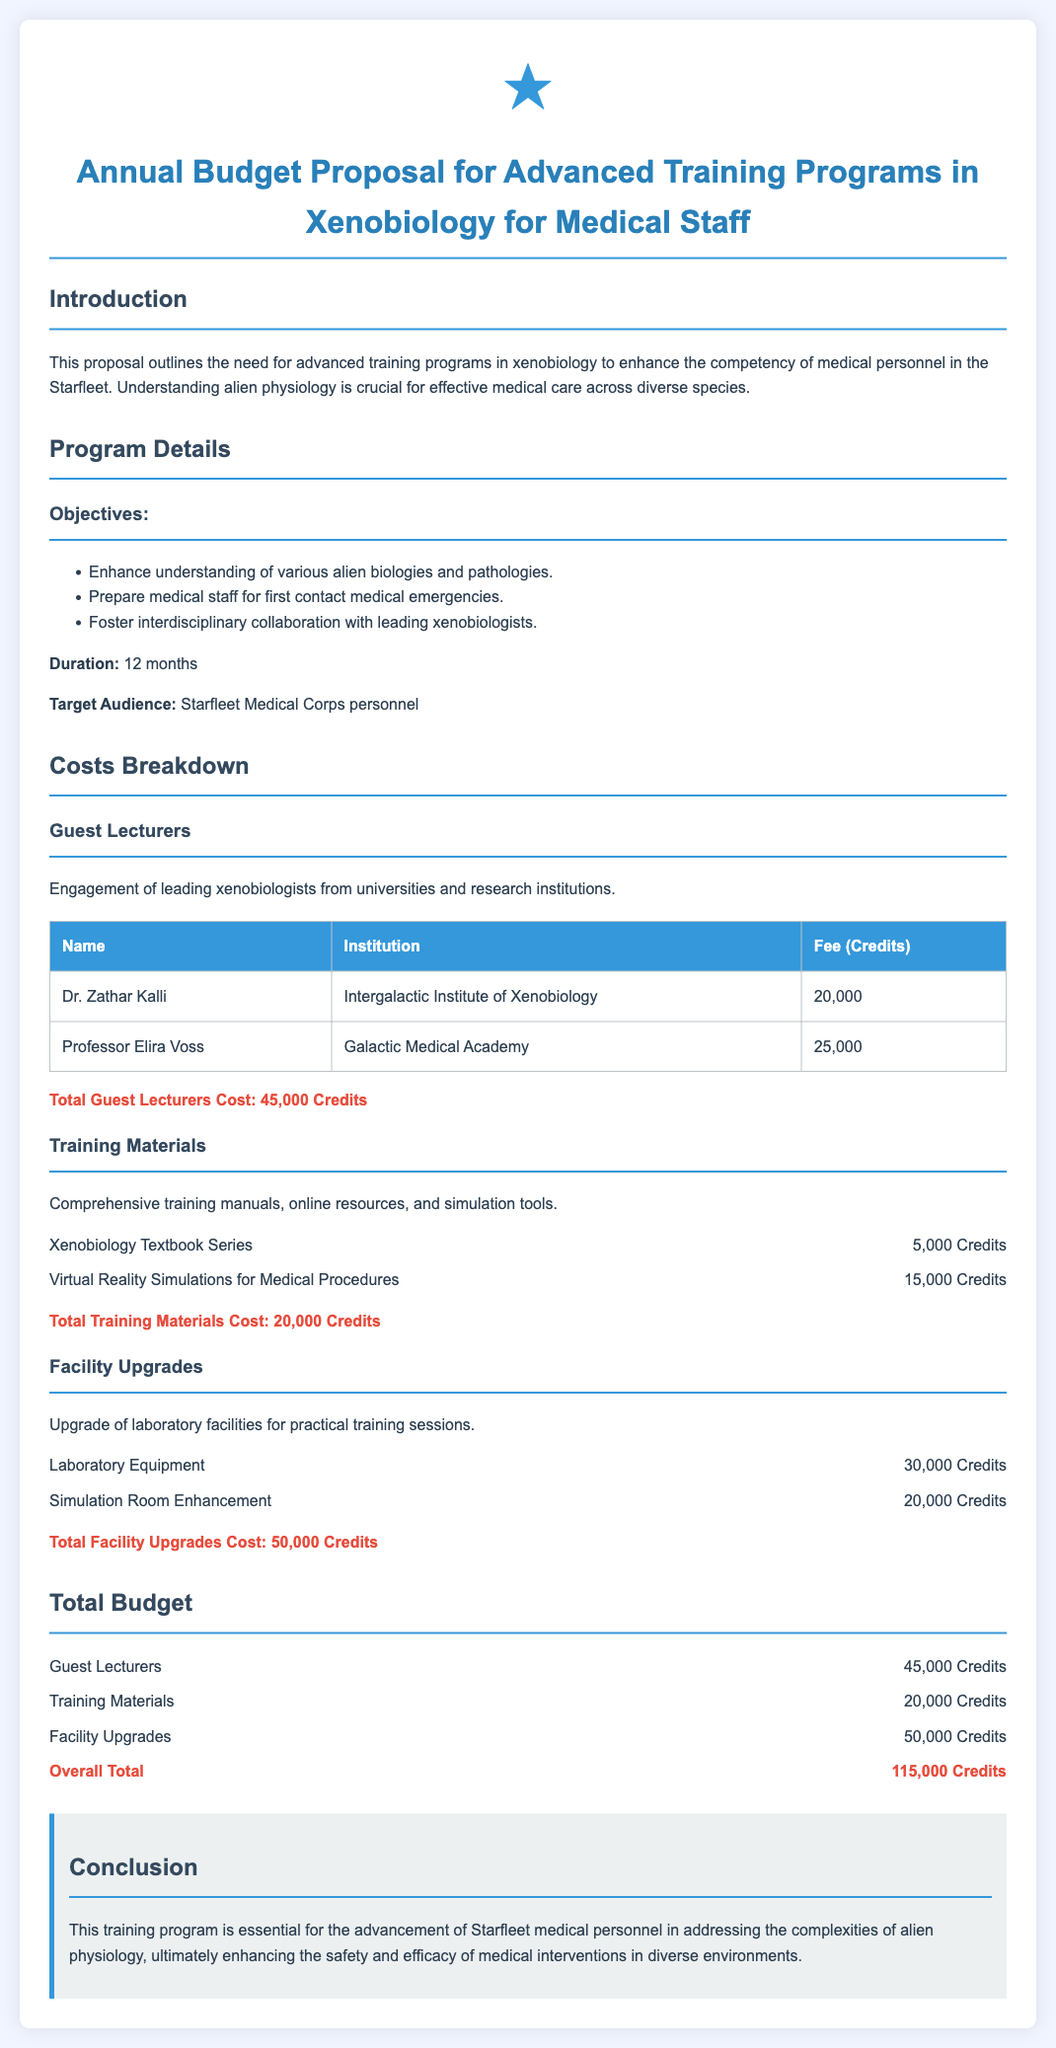What is the total cost for guest lecturers? The total cost for guest lecturers is listed in the document after the detailed breakdown of the guest lecturer costs.
Answer: 45,000 Credits What is the total cost allocated for training materials? The total training materials cost is summarized at the end of the section detailing training materials in the document.
Answer: 20,000 Credits What are the names of the guest lecturers? The document specifies Dr. Zathar Kalli and Professor Elira Voss in the guest lecturer section.
Answer: Dr. Zathar Kalli, Professor Elira Voss How much will the virtual reality simulations cost? The document lists the cost of virtual reality simulations specifically in the training materials section.
Answer: 15,000 Credits What is the overall total budget proposal? The overall total is found at the end of the total budget section, summarizing all costs.
Answer: 115,000 Credits What is the duration of the training program? The document mentions the duration of the program in the program details section.
Answer: 12 months What is the purpose of training programs in xenobiology? The introduction outlines the need for these training programs, specifically highlighting their purposes.
Answer: Enhance understanding of alien biologies and pathologies What are the total costs for facility upgrades? The facility upgrades totals are presented after detailing individual upgrade costs in the facility upgrades section.
Answer: 50,000 Credits How many guest lecturers are mentioned in the document? The number of guest lecturers can be counted as specified in the guest lecturers section of the document.
Answer: 2 